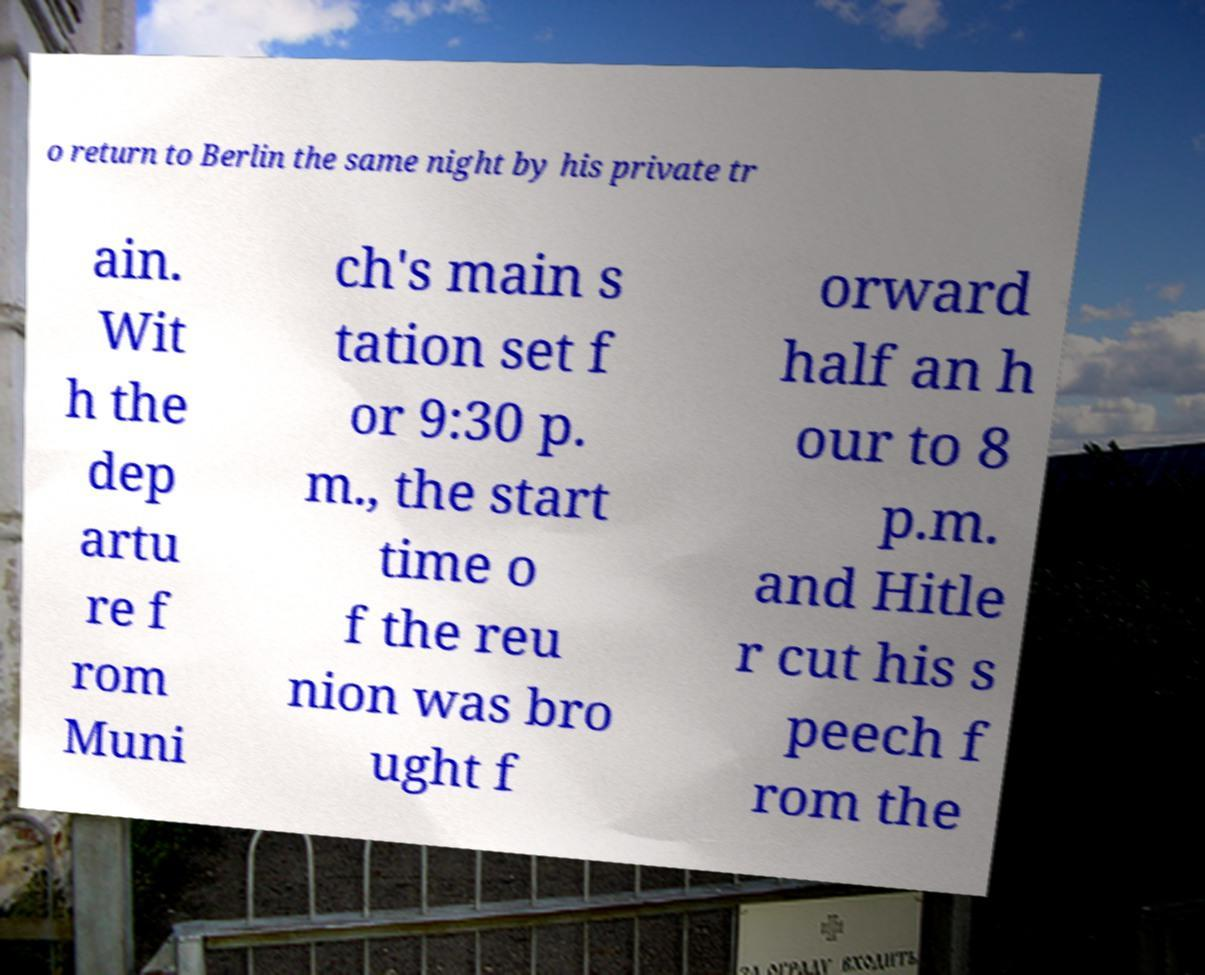What messages or text are displayed in this image? I need them in a readable, typed format. o return to Berlin the same night by his private tr ain. Wit h the dep artu re f rom Muni ch's main s tation set f or 9:30 p. m., the start time o f the reu nion was bro ught f orward half an h our to 8 p.m. and Hitle r cut his s peech f rom the 